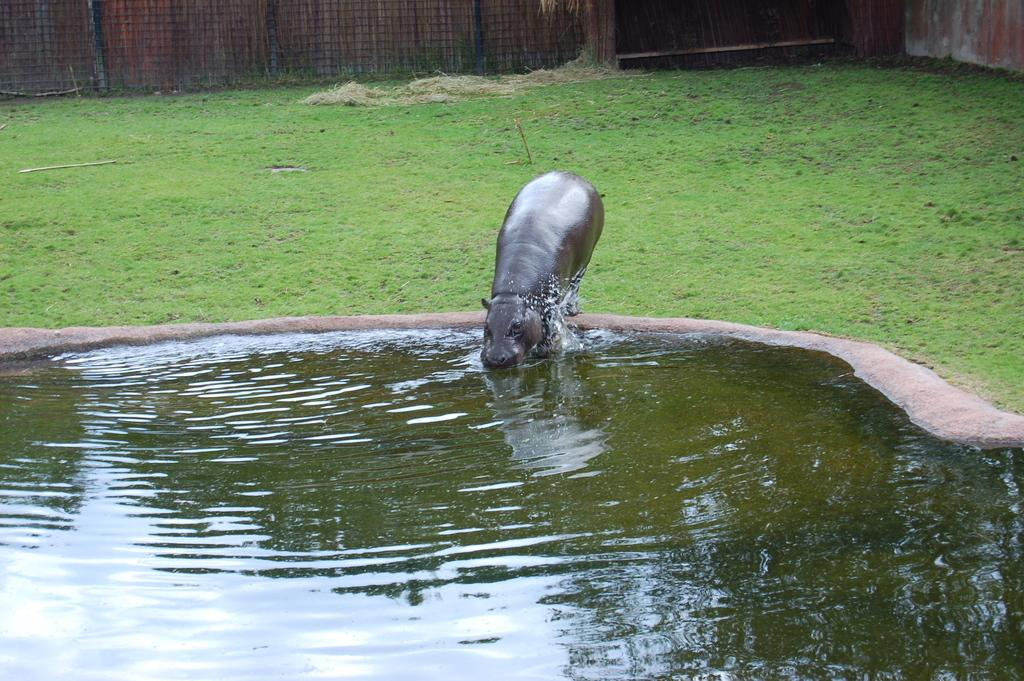What animal is present in the image? There is a hippopotamus in the image. Where is the hippopotamus located in relation to the pond? The hippopotamus is beside a pond in the image. What type of vegetation can be seen in the image? There is grass visible in the image. What type of structure is present in the image? There is a wooden wall and a fence in the image. What time of day is it in the image? The time of day cannot be determined from the image, as there are no clues or indicators of time present. 